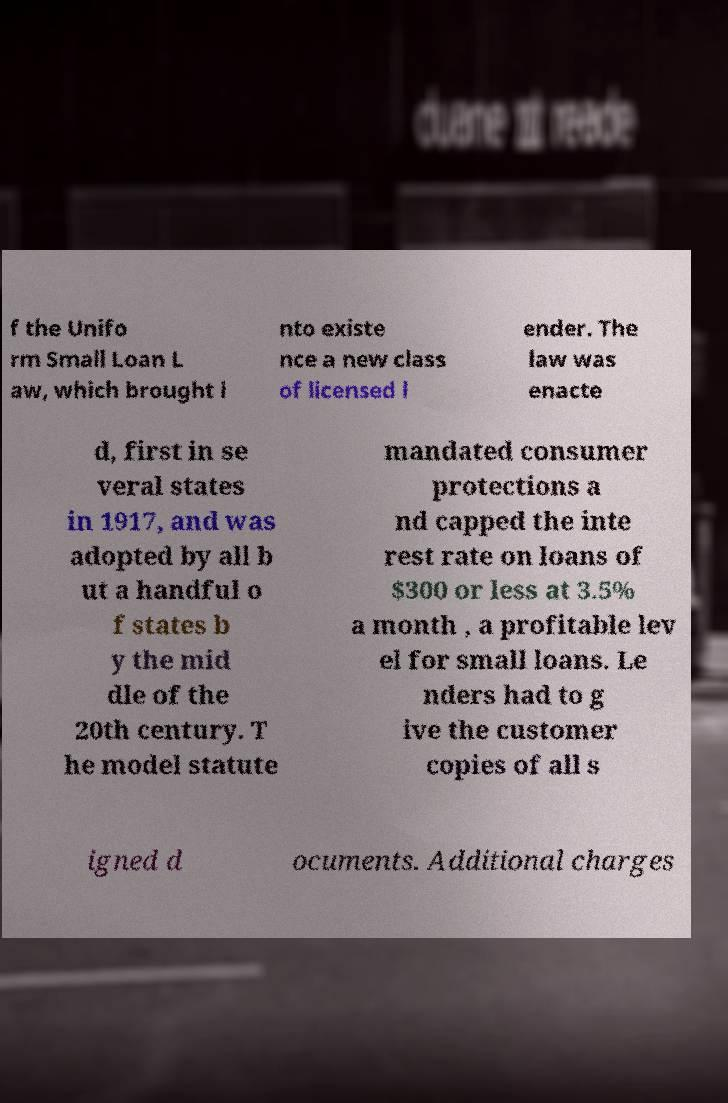What messages or text are displayed in this image? I need them in a readable, typed format. f the Unifo rm Small Loan L aw, which brought i nto existe nce a new class of licensed l ender. The law was enacte d, first in se veral states in 1917, and was adopted by all b ut a handful o f states b y the mid dle of the 20th century. T he model statute mandated consumer protections a nd capped the inte rest rate on loans of $300 or less at 3.5% a month , a profitable lev el for small loans. Le nders had to g ive the customer copies of all s igned d ocuments. Additional charges 